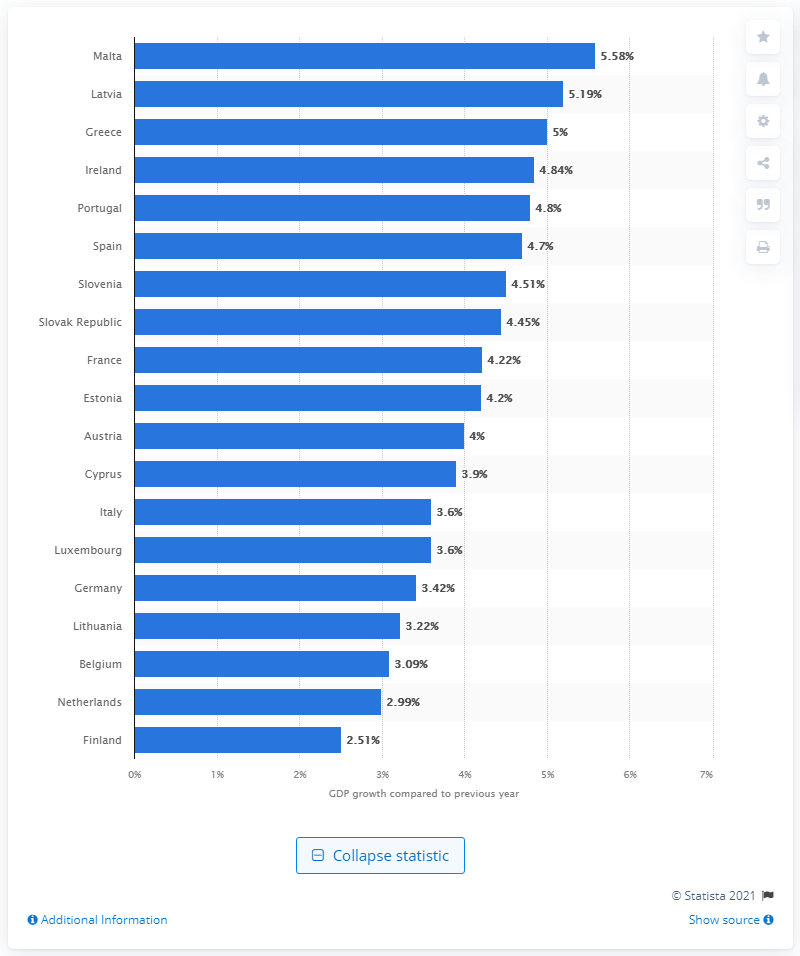Outline some significant characteristics in this image. According to the forecast, Germany's gross domestic product is expected to grow by 3.42% in 2022. 